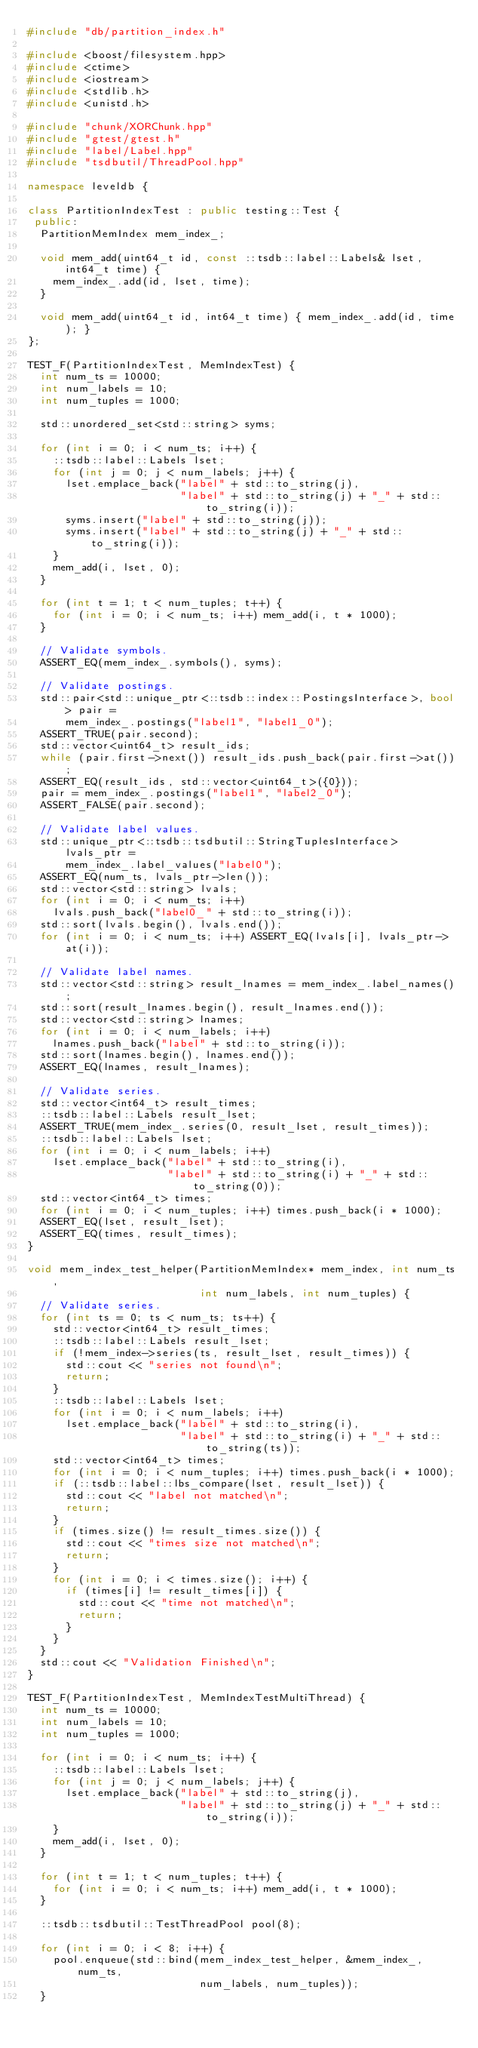Convert code to text. <code><loc_0><loc_0><loc_500><loc_500><_C++_>#include "db/partition_index.h"

#include <boost/filesystem.hpp>
#include <ctime>
#include <iostream>
#include <stdlib.h>
#include <unistd.h>

#include "chunk/XORChunk.hpp"
#include "gtest/gtest.h"
#include "label/Label.hpp"
#include "tsdbutil/ThreadPool.hpp"

namespace leveldb {

class PartitionIndexTest : public testing::Test {
 public:
  PartitionMemIndex mem_index_;

  void mem_add(uint64_t id, const ::tsdb::label::Labels& lset, int64_t time) {
    mem_index_.add(id, lset, time);
  }

  void mem_add(uint64_t id, int64_t time) { mem_index_.add(id, time); }
};

TEST_F(PartitionIndexTest, MemIndexTest) {
  int num_ts = 10000;
  int num_labels = 10;
  int num_tuples = 1000;

  std::unordered_set<std::string> syms;

  for (int i = 0; i < num_ts; i++) {
    ::tsdb::label::Labels lset;
    for (int j = 0; j < num_labels; j++) {
      lset.emplace_back("label" + std::to_string(j),
                        "label" + std::to_string(j) + "_" + std::to_string(i));
      syms.insert("label" + std::to_string(j));
      syms.insert("label" + std::to_string(j) + "_" + std::to_string(i));
    }
    mem_add(i, lset, 0);
  }

  for (int t = 1; t < num_tuples; t++) {
    for (int i = 0; i < num_ts; i++) mem_add(i, t * 1000);
  }

  // Validate symbols.
  ASSERT_EQ(mem_index_.symbols(), syms);

  // Validate postings.
  std::pair<std::unique_ptr<::tsdb::index::PostingsInterface>, bool> pair =
      mem_index_.postings("label1", "label1_0");
  ASSERT_TRUE(pair.second);
  std::vector<uint64_t> result_ids;
  while (pair.first->next()) result_ids.push_back(pair.first->at());
  ASSERT_EQ(result_ids, std::vector<uint64_t>({0}));
  pair = mem_index_.postings("label1", "label2_0");
  ASSERT_FALSE(pair.second);

  // Validate label values.
  std::unique_ptr<::tsdb::tsdbutil::StringTuplesInterface> lvals_ptr =
      mem_index_.label_values("label0");
  ASSERT_EQ(num_ts, lvals_ptr->len());
  std::vector<std::string> lvals;
  for (int i = 0; i < num_ts; i++)
    lvals.push_back("label0_" + std::to_string(i));
  std::sort(lvals.begin(), lvals.end());
  for (int i = 0; i < num_ts; i++) ASSERT_EQ(lvals[i], lvals_ptr->at(i));

  // Validate label names.
  std::vector<std::string> result_lnames = mem_index_.label_names();
  std::sort(result_lnames.begin(), result_lnames.end());
  std::vector<std::string> lnames;
  for (int i = 0; i < num_labels; i++)
    lnames.push_back("label" + std::to_string(i));
  std::sort(lnames.begin(), lnames.end());
  ASSERT_EQ(lnames, result_lnames);

  // Validate series.
  std::vector<int64_t> result_times;
  ::tsdb::label::Labels result_lset;
  ASSERT_TRUE(mem_index_.series(0, result_lset, result_times));
  ::tsdb::label::Labels lset;
  for (int i = 0; i < num_labels; i++)
    lset.emplace_back("label" + std::to_string(i),
                      "label" + std::to_string(i) + "_" + std::to_string(0));
  std::vector<int64_t> times;
  for (int i = 0; i < num_tuples; i++) times.push_back(i * 1000);
  ASSERT_EQ(lset, result_lset);
  ASSERT_EQ(times, result_times);
}

void mem_index_test_helper(PartitionMemIndex* mem_index, int num_ts,
                           int num_labels, int num_tuples) {
  // Validate series.
  for (int ts = 0; ts < num_ts; ts++) {
    std::vector<int64_t> result_times;
    ::tsdb::label::Labels result_lset;
    if (!mem_index->series(ts, result_lset, result_times)) {
      std::cout << "series not found\n";
      return;
    }
    ::tsdb::label::Labels lset;
    for (int i = 0; i < num_labels; i++)
      lset.emplace_back("label" + std::to_string(i),
                        "label" + std::to_string(i) + "_" + std::to_string(ts));
    std::vector<int64_t> times;
    for (int i = 0; i < num_tuples; i++) times.push_back(i * 1000);
    if (::tsdb::label::lbs_compare(lset, result_lset)) {
      std::cout << "label not matched\n";
      return;
    }
    if (times.size() != result_times.size()) {
      std::cout << "times size not matched\n";
      return;
    }
    for (int i = 0; i < times.size(); i++) {
      if (times[i] != result_times[i]) {
        std::cout << "time not matched\n";
        return;
      }
    }
  }
  std::cout << "Validation Finished\n";
}

TEST_F(PartitionIndexTest, MemIndexTestMultiThread) {
  int num_ts = 10000;
  int num_labels = 10;
  int num_tuples = 1000;

  for (int i = 0; i < num_ts; i++) {
    ::tsdb::label::Labels lset;
    for (int j = 0; j < num_labels; j++) {
      lset.emplace_back("label" + std::to_string(j),
                        "label" + std::to_string(j) + "_" + std::to_string(i));
    }
    mem_add(i, lset, 0);
  }

  for (int t = 1; t < num_tuples; t++) {
    for (int i = 0; i < num_ts; i++) mem_add(i, t * 1000);
  }

  ::tsdb::tsdbutil::TestThreadPool pool(8);

  for (int i = 0; i < 8; i++) {
    pool.enqueue(std::bind(mem_index_test_helper, &mem_index_, num_ts,
                           num_labels, num_tuples));
  }</code> 